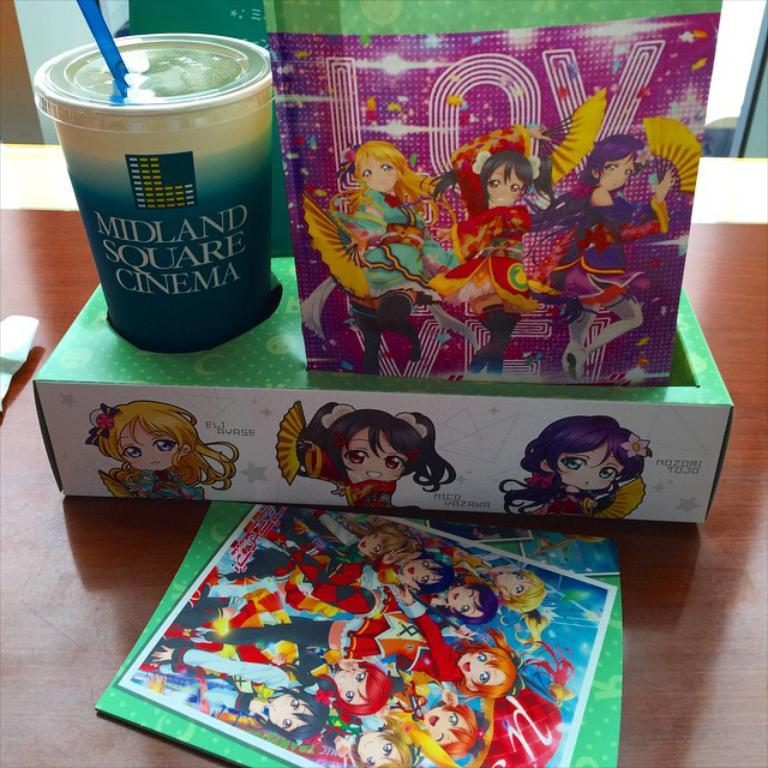What is one of the objects visible in the image? There is a glass in the image. What is another object visible in the image? There is a box in the image. Can you describe the other objects in the image? There are other objects in the image, and they have animated people pictures on them. What is the surface on which the objects are placed? The objects are on a wooden surface. How many toes can be seen on the animated people pictures in the image? There are no toes visible in the image, as the objects have animated people pictures, not actual people. 